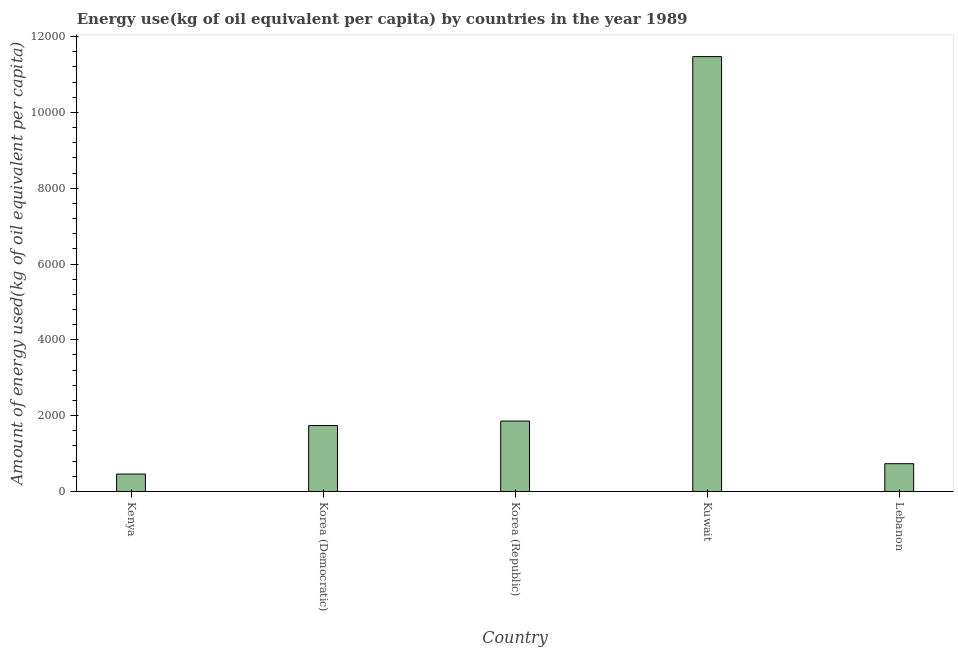What is the title of the graph?
Offer a very short reply. Energy use(kg of oil equivalent per capita) by countries in the year 1989. What is the label or title of the Y-axis?
Give a very brief answer. Amount of energy used(kg of oil equivalent per capita). What is the amount of energy used in Korea (Democratic)?
Your answer should be very brief. 1739.2. Across all countries, what is the maximum amount of energy used?
Give a very brief answer. 1.15e+04. Across all countries, what is the minimum amount of energy used?
Your answer should be compact. 460.13. In which country was the amount of energy used maximum?
Your response must be concise. Kuwait. In which country was the amount of energy used minimum?
Your answer should be very brief. Kenya. What is the sum of the amount of energy used?
Provide a short and direct response. 1.63e+04. What is the difference between the amount of energy used in Korea (Democratic) and Korea (Republic)?
Keep it short and to the point. -118.1. What is the average amount of energy used per country?
Provide a short and direct response. 3251.91. What is the median amount of energy used?
Provide a short and direct response. 1739.2. In how many countries, is the amount of energy used greater than 5600 kg?
Offer a terse response. 1. What is the ratio of the amount of energy used in Korea (Democratic) to that in Kuwait?
Make the answer very short. 0.15. Is the amount of energy used in Korea (Democratic) less than that in Lebanon?
Make the answer very short. No. Is the difference between the amount of energy used in Korea (Democratic) and Kuwait greater than the difference between any two countries?
Make the answer very short. No. What is the difference between the highest and the second highest amount of energy used?
Offer a very short reply. 9612.95. Is the sum of the amount of energy used in Kenya and Korea (Democratic) greater than the maximum amount of energy used across all countries?
Offer a terse response. No. What is the difference between the highest and the lowest amount of energy used?
Keep it short and to the point. 1.10e+04. How many bars are there?
Your answer should be very brief. 5. Are all the bars in the graph horizontal?
Offer a terse response. No. What is the difference between two consecutive major ticks on the Y-axis?
Offer a terse response. 2000. What is the Amount of energy used(kg of oil equivalent per capita) of Kenya?
Ensure brevity in your answer.  460.13. What is the Amount of energy used(kg of oil equivalent per capita) of Korea (Democratic)?
Your response must be concise. 1739.2. What is the Amount of energy used(kg of oil equivalent per capita) of Korea (Republic)?
Provide a short and direct response. 1857.3. What is the Amount of energy used(kg of oil equivalent per capita) in Kuwait?
Provide a short and direct response. 1.15e+04. What is the Amount of energy used(kg of oil equivalent per capita) of Lebanon?
Your answer should be compact. 732.69. What is the difference between the Amount of energy used(kg of oil equivalent per capita) in Kenya and Korea (Democratic)?
Provide a short and direct response. -1279.07. What is the difference between the Amount of energy used(kg of oil equivalent per capita) in Kenya and Korea (Republic)?
Your response must be concise. -1397.17. What is the difference between the Amount of energy used(kg of oil equivalent per capita) in Kenya and Kuwait?
Your answer should be very brief. -1.10e+04. What is the difference between the Amount of energy used(kg of oil equivalent per capita) in Kenya and Lebanon?
Your response must be concise. -272.56. What is the difference between the Amount of energy used(kg of oil equivalent per capita) in Korea (Democratic) and Korea (Republic)?
Provide a short and direct response. -118.1. What is the difference between the Amount of energy used(kg of oil equivalent per capita) in Korea (Democratic) and Kuwait?
Make the answer very short. -9731.05. What is the difference between the Amount of energy used(kg of oil equivalent per capita) in Korea (Democratic) and Lebanon?
Your answer should be compact. 1006.51. What is the difference between the Amount of energy used(kg of oil equivalent per capita) in Korea (Republic) and Kuwait?
Your answer should be compact. -9612.95. What is the difference between the Amount of energy used(kg of oil equivalent per capita) in Korea (Republic) and Lebanon?
Provide a short and direct response. 1124.61. What is the difference between the Amount of energy used(kg of oil equivalent per capita) in Kuwait and Lebanon?
Provide a short and direct response. 1.07e+04. What is the ratio of the Amount of energy used(kg of oil equivalent per capita) in Kenya to that in Korea (Democratic)?
Your response must be concise. 0.27. What is the ratio of the Amount of energy used(kg of oil equivalent per capita) in Kenya to that in Korea (Republic)?
Your answer should be compact. 0.25. What is the ratio of the Amount of energy used(kg of oil equivalent per capita) in Kenya to that in Kuwait?
Make the answer very short. 0.04. What is the ratio of the Amount of energy used(kg of oil equivalent per capita) in Kenya to that in Lebanon?
Make the answer very short. 0.63. What is the ratio of the Amount of energy used(kg of oil equivalent per capita) in Korea (Democratic) to that in Korea (Republic)?
Ensure brevity in your answer.  0.94. What is the ratio of the Amount of energy used(kg of oil equivalent per capita) in Korea (Democratic) to that in Kuwait?
Your response must be concise. 0.15. What is the ratio of the Amount of energy used(kg of oil equivalent per capita) in Korea (Democratic) to that in Lebanon?
Offer a very short reply. 2.37. What is the ratio of the Amount of energy used(kg of oil equivalent per capita) in Korea (Republic) to that in Kuwait?
Your answer should be very brief. 0.16. What is the ratio of the Amount of energy used(kg of oil equivalent per capita) in Korea (Republic) to that in Lebanon?
Provide a succinct answer. 2.54. What is the ratio of the Amount of energy used(kg of oil equivalent per capita) in Kuwait to that in Lebanon?
Your answer should be very brief. 15.65. 